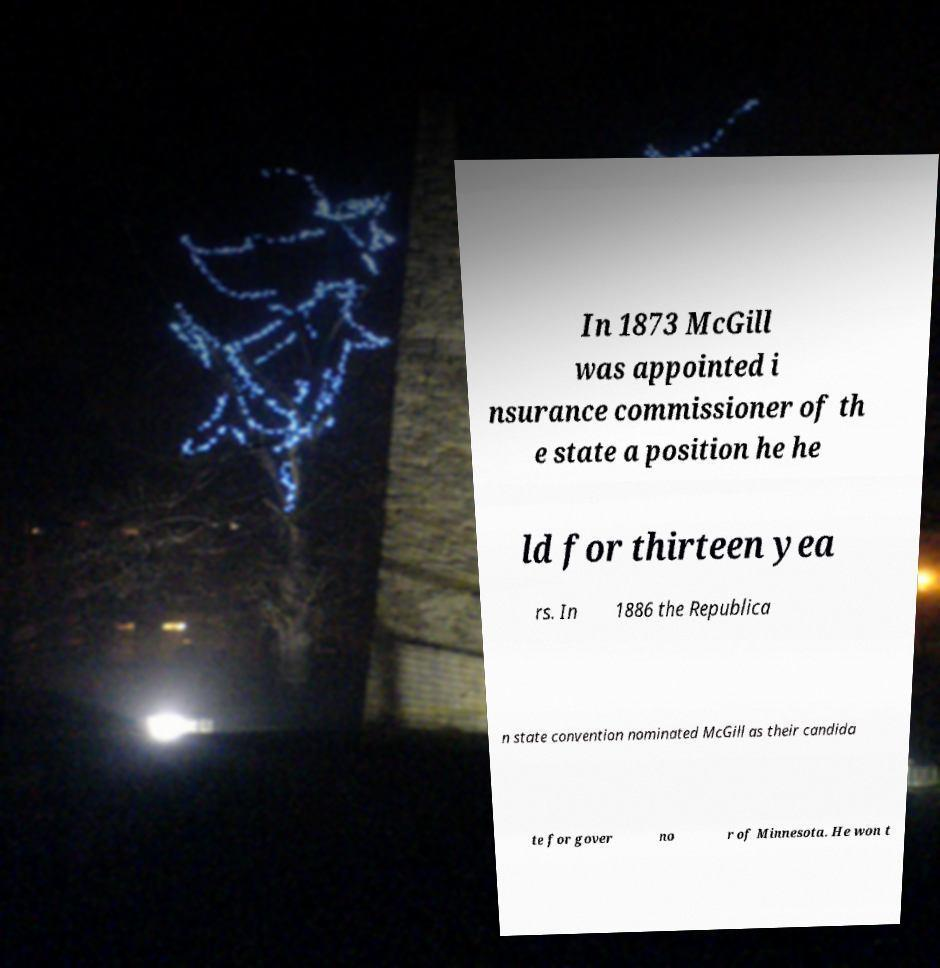Can you read and provide the text displayed in the image?This photo seems to have some interesting text. Can you extract and type it out for me? In 1873 McGill was appointed i nsurance commissioner of th e state a position he he ld for thirteen yea rs. In 1886 the Republica n state convention nominated McGill as their candida te for gover no r of Minnesota. He won t 